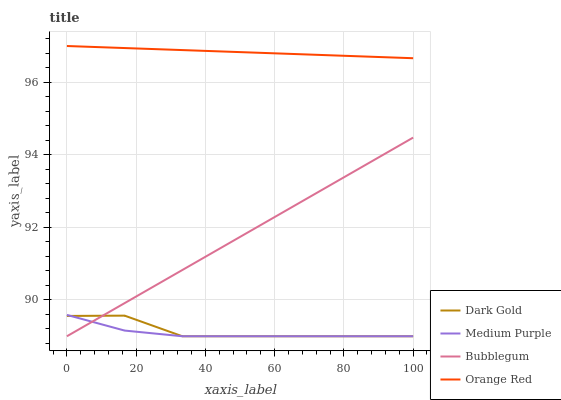Does Medium Purple have the minimum area under the curve?
Answer yes or no. Yes. Does Orange Red have the maximum area under the curve?
Answer yes or no. Yes. Does Bubblegum have the minimum area under the curve?
Answer yes or no. No. Does Bubblegum have the maximum area under the curve?
Answer yes or no. No. Is Orange Red the smoothest?
Answer yes or no. Yes. Is Dark Gold the roughest?
Answer yes or no. Yes. Is Bubblegum the smoothest?
Answer yes or no. No. Is Bubblegum the roughest?
Answer yes or no. No. Does Medium Purple have the lowest value?
Answer yes or no. Yes. Does Orange Red have the lowest value?
Answer yes or no. No. Does Orange Red have the highest value?
Answer yes or no. Yes. Does Bubblegum have the highest value?
Answer yes or no. No. Is Bubblegum less than Orange Red?
Answer yes or no. Yes. Is Orange Red greater than Dark Gold?
Answer yes or no. Yes. Does Bubblegum intersect Medium Purple?
Answer yes or no. Yes. Is Bubblegum less than Medium Purple?
Answer yes or no. No. Is Bubblegum greater than Medium Purple?
Answer yes or no. No. Does Bubblegum intersect Orange Red?
Answer yes or no. No. 